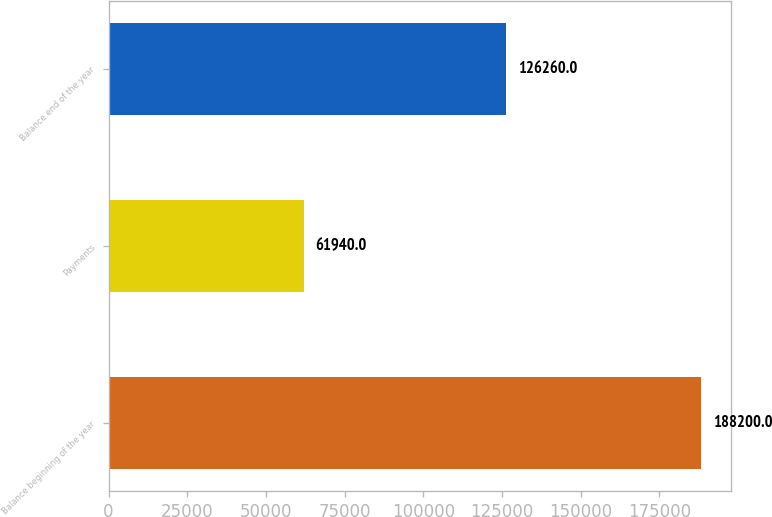Convert chart to OTSL. <chart><loc_0><loc_0><loc_500><loc_500><bar_chart><fcel>Balance beginning of the year<fcel>Payments<fcel>Balance end of the year<nl><fcel>188200<fcel>61940<fcel>126260<nl></chart> 